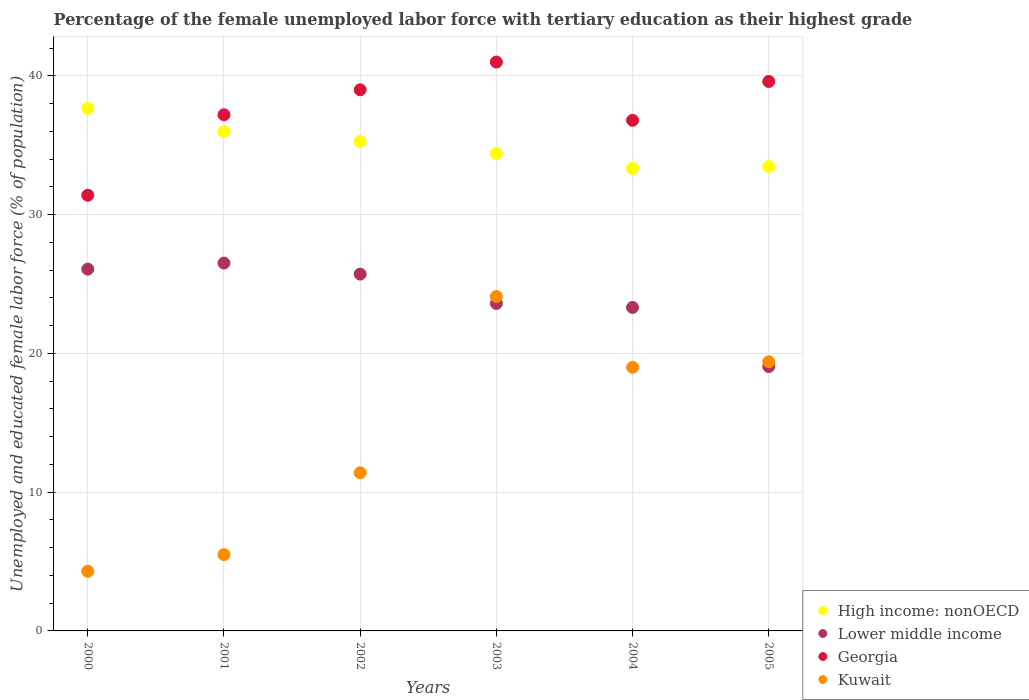How many different coloured dotlines are there?
Provide a succinct answer. 4. Across all years, what is the maximum percentage of the unemployed female labor force with tertiary education in Lower middle income?
Provide a succinct answer. 26.51. Across all years, what is the minimum percentage of the unemployed female labor force with tertiary education in Georgia?
Your response must be concise. 31.4. In which year was the percentage of the unemployed female labor force with tertiary education in Lower middle income minimum?
Your answer should be very brief. 2005. What is the total percentage of the unemployed female labor force with tertiary education in Lower middle income in the graph?
Provide a succinct answer. 144.27. What is the difference between the percentage of the unemployed female labor force with tertiary education in Lower middle income in 2002 and that in 2003?
Give a very brief answer. 2.11. What is the difference between the percentage of the unemployed female labor force with tertiary education in High income: nonOECD in 2002 and the percentage of the unemployed female labor force with tertiary education in Georgia in 2003?
Give a very brief answer. -5.73. What is the average percentage of the unemployed female labor force with tertiary education in Georgia per year?
Provide a succinct answer. 37.5. In the year 2002, what is the difference between the percentage of the unemployed female labor force with tertiary education in Kuwait and percentage of the unemployed female labor force with tertiary education in Lower middle income?
Provide a short and direct response. -14.31. What is the ratio of the percentage of the unemployed female labor force with tertiary education in High income: nonOECD in 2002 to that in 2004?
Your answer should be compact. 1.06. Is the percentage of the unemployed female labor force with tertiary education in High income: nonOECD in 2003 less than that in 2005?
Provide a short and direct response. No. Is the difference between the percentage of the unemployed female labor force with tertiary education in Kuwait in 2002 and 2005 greater than the difference between the percentage of the unemployed female labor force with tertiary education in Lower middle income in 2002 and 2005?
Offer a terse response. No. What is the difference between the highest and the second highest percentage of the unemployed female labor force with tertiary education in Georgia?
Offer a terse response. 1.4. What is the difference between the highest and the lowest percentage of the unemployed female labor force with tertiary education in Kuwait?
Provide a succinct answer. 19.8. In how many years, is the percentage of the unemployed female labor force with tertiary education in Kuwait greater than the average percentage of the unemployed female labor force with tertiary education in Kuwait taken over all years?
Provide a short and direct response. 3. Is the sum of the percentage of the unemployed female labor force with tertiary education in Lower middle income in 2001 and 2005 greater than the maximum percentage of the unemployed female labor force with tertiary education in Kuwait across all years?
Your answer should be compact. Yes. Is it the case that in every year, the sum of the percentage of the unemployed female labor force with tertiary education in Lower middle income and percentage of the unemployed female labor force with tertiary education in Georgia  is greater than the sum of percentage of the unemployed female labor force with tertiary education in High income: nonOECD and percentage of the unemployed female labor force with tertiary education in Kuwait?
Give a very brief answer. Yes. Is it the case that in every year, the sum of the percentage of the unemployed female labor force with tertiary education in Georgia and percentage of the unemployed female labor force with tertiary education in Lower middle income  is greater than the percentage of the unemployed female labor force with tertiary education in Kuwait?
Keep it short and to the point. Yes. Is the percentage of the unemployed female labor force with tertiary education in Georgia strictly greater than the percentage of the unemployed female labor force with tertiary education in High income: nonOECD over the years?
Your response must be concise. No. Is the percentage of the unemployed female labor force with tertiary education in Georgia strictly less than the percentage of the unemployed female labor force with tertiary education in Kuwait over the years?
Give a very brief answer. No. How many dotlines are there?
Offer a very short reply. 4. What is the difference between two consecutive major ticks on the Y-axis?
Your response must be concise. 10. Are the values on the major ticks of Y-axis written in scientific E-notation?
Make the answer very short. No. Does the graph contain any zero values?
Ensure brevity in your answer.  No. Does the graph contain grids?
Give a very brief answer. Yes. Where does the legend appear in the graph?
Your answer should be compact. Bottom right. How many legend labels are there?
Make the answer very short. 4. What is the title of the graph?
Your response must be concise. Percentage of the female unemployed labor force with tertiary education as their highest grade. What is the label or title of the X-axis?
Provide a succinct answer. Years. What is the label or title of the Y-axis?
Provide a succinct answer. Unemployed and educated female labor force (% of population). What is the Unemployed and educated female labor force (% of population) of High income: nonOECD in 2000?
Provide a short and direct response. 37.66. What is the Unemployed and educated female labor force (% of population) of Lower middle income in 2000?
Offer a very short reply. 26.07. What is the Unemployed and educated female labor force (% of population) of Georgia in 2000?
Your answer should be compact. 31.4. What is the Unemployed and educated female labor force (% of population) of Kuwait in 2000?
Your answer should be very brief. 4.3. What is the Unemployed and educated female labor force (% of population) of High income: nonOECD in 2001?
Provide a short and direct response. 35.98. What is the Unemployed and educated female labor force (% of population) in Lower middle income in 2001?
Offer a very short reply. 26.51. What is the Unemployed and educated female labor force (% of population) in Georgia in 2001?
Provide a short and direct response. 37.2. What is the Unemployed and educated female labor force (% of population) of High income: nonOECD in 2002?
Ensure brevity in your answer.  35.27. What is the Unemployed and educated female labor force (% of population) of Lower middle income in 2002?
Ensure brevity in your answer.  25.71. What is the Unemployed and educated female labor force (% of population) of Kuwait in 2002?
Your answer should be compact. 11.4. What is the Unemployed and educated female labor force (% of population) in High income: nonOECD in 2003?
Provide a short and direct response. 34.41. What is the Unemployed and educated female labor force (% of population) in Lower middle income in 2003?
Keep it short and to the point. 23.6. What is the Unemployed and educated female labor force (% of population) in Kuwait in 2003?
Ensure brevity in your answer.  24.1. What is the Unemployed and educated female labor force (% of population) in High income: nonOECD in 2004?
Your answer should be compact. 33.33. What is the Unemployed and educated female labor force (% of population) of Lower middle income in 2004?
Your answer should be compact. 23.32. What is the Unemployed and educated female labor force (% of population) in Georgia in 2004?
Your response must be concise. 36.8. What is the Unemployed and educated female labor force (% of population) of High income: nonOECD in 2005?
Keep it short and to the point. 33.46. What is the Unemployed and educated female labor force (% of population) of Lower middle income in 2005?
Your response must be concise. 19.05. What is the Unemployed and educated female labor force (% of population) in Georgia in 2005?
Provide a short and direct response. 39.6. What is the Unemployed and educated female labor force (% of population) of Kuwait in 2005?
Provide a short and direct response. 19.4. Across all years, what is the maximum Unemployed and educated female labor force (% of population) of High income: nonOECD?
Make the answer very short. 37.66. Across all years, what is the maximum Unemployed and educated female labor force (% of population) of Lower middle income?
Your answer should be compact. 26.51. Across all years, what is the maximum Unemployed and educated female labor force (% of population) of Kuwait?
Offer a very short reply. 24.1. Across all years, what is the minimum Unemployed and educated female labor force (% of population) of High income: nonOECD?
Provide a short and direct response. 33.33. Across all years, what is the minimum Unemployed and educated female labor force (% of population) of Lower middle income?
Provide a succinct answer. 19.05. Across all years, what is the minimum Unemployed and educated female labor force (% of population) of Georgia?
Your answer should be very brief. 31.4. Across all years, what is the minimum Unemployed and educated female labor force (% of population) in Kuwait?
Your response must be concise. 4.3. What is the total Unemployed and educated female labor force (% of population) of High income: nonOECD in the graph?
Offer a very short reply. 210.12. What is the total Unemployed and educated female labor force (% of population) in Lower middle income in the graph?
Your answer should be very brief. 144.27. What is the total Unemployed and educated female labor force (% of population) of Georgia in the graph?
Offer a very short reply. 225. What is the total Unemployed and educated female labor force (% of population) of Kuwait in the graph?
Make the answer very short. 83.7. What is the difference between the Unemployed and educated female labor force (% of population) in High income: nonOECD in 2000 and that in 2001?
Your answer should be compact. 1.68. What is the difference between the Unemployed and educated female labor force (% of population) in Lower middle income in 2000 and that in 2001?
Provide a succinct answer. -0.44. What is the difference between the Unemployed and educated female labor force (% of population) in Kuwait in 2000 and that in 2001?
Offer a terse response. -1.2. What is the difference between the Unemployed and educated female labor force (% of population) in High income: nonOECD in 2000 and that in 2002?
Your response must be concise. 2.39. What is the difference between the Unemployed and educated female labor force (% of population) of Lower middle income in 2000 and that in 2002?
Your answer should be compact. 0.36. What is the difference between the Unemployed and educated female labor force (% of population) of Georgia in 2000 and that in 2002?
Your response must be concise. -7.6. What is the difference between the Unemployed and educated female labor force (% of population) of Kuwait in 2000 and that in 2002?
Your response must be concise. -7.1. What is the difference between the Unemployed and educated female labor force (% of population) in High income: nonOECD in 2000 and that in 2003?
Offer a terse response. 3.25. What is the difference between the Unemployed and educated female labor force (% of population) in Lower middle income in 2000 and that in 2003?
Your response must be concise. 2.47. What is the difference between the Unemployed and educated female labor force (% of population) of Kuwait in 2000 and that in 2003?
Make the answer very short. -19.8. What is the difference between the Unemployed and educated female labor force (% of population) in High income: nonOECD in 2000 and that in 2004?
Your answer should be very brief. 4.34. What is the difference between the Unemployed and educated female labor force (% of population) of Lower middle income in 2000 and that in 2004?
Offer a terse response. 2.76. What is the difference between the Unemployed and educated female labor force (% of population) in Kuwait in 2000 and that in 2004?
Provide a succinct answer. -14.7. What is the difference between the Unemployed and educated female labor force (% of population) of High income: nonOECD in 2000 and that in 2005?
Offer a very short reply. 4.2. What is the difference between the Unemployed and educated female labor force (% of population) in Lower middle income in 2000 and that in 2005?
Give a very brief answer. 7.02. What is the difference between the Unemployed and educated female labor force (% of population) in Kuwait in 2000 and that in 2005?
Offer a very short reply. -15.1. What is the difference between the Unemployed and educated female labor force (% of population) in High income: nonOECD in 2001 and that in 2002?
Your response must be concise. 0.71. What is the difference between the Unemployed and educated female labor force (% of population) in Lower middle income in 2001 and that in 2002?
Make the answer very short. 0.8. What is the difference between the Unemployed and educated female labor force (% of population) in Georgia in 2001 and that in 2002?
Make the answer very short. -1.8. What is the difference between the Unemployed and educated female labor force (% of population) in High income: nonOECD in 2001 and that in 2003?
Make the answer very short. 1.57. What is the difference between the Unemployed and educated female labor force (% of population) in Lower middle income in 2001 and that in 2003?
Give a very brief answer. 2.91. What is the difference between the Unemployed and educated female labor force (% of population) of Georgia in 2001 and that in 2003?
Ensure brevity in your answer.  -3.8. What is the difference between the Unemployed and educated female labor force (% of population) in Kuwait in 2001 and that in 2003?
Your response must be concise. -18.6. What is the difference between the Unemployed and educated female labor force (% of population) of High income: nonOECD in 2001 and that in 2004?
Ensure brevity in your answer.  2.65. What is the difference between the Unemployed and educated female labor force (% of population) of Lower middle income in 2001 and that in 2004?
Make the answer very short. 3.2. What is the difference between the Unemployed and educated female labor force (% of population) of High income: nonOECD in 2001 and that in 2005?
Give a very brief answer. 2.52. What is the difference between the Unemployed and educated female labor force (% of population) of Lower middle income in 2001 and that in 2005?
Provide a short and direct response. 7.46. What is the difference between the Unemployed and educated female labor force (% of population) in High income: nonOECD in 2002 and that in 2003?
Your response must be concise. 0.86. What is the difference between the Unemployed and educated female labor force (% of population) in Lower middle income in 2002 and that in 2003?
Offer a very short reply. 2.11. What is the difference between the Unemployed and educated female labor force (% of population) of Georgia in 2002 and that in 2003?
Make the answer very short. -2. What is the difference between the Unemployed and educated female labor force (% of population) of High income: nonOECD in 2002 and that in 2004?
Your answer should be very brief. 1.95. What is the difference between the Unemployed and educated female labor force (% of population) of Lower middle income in 2002 and that in 2004?
Offer a very short reply. 2.4. What is the difference between the Unemployed and educated female labor force (% of population) in Kuwait in 2002 and that in 2004?
Your answer should be very brief. -7.6. What is the difference between the Unemployed and educated female labor force (% of population) of High income: nonOECD in 2002 and that in 2005?
Keep it short and to the point. 1.81. What is the difference between the Unemployed and educated female labor force (% of population) of Lower middle income in 2002 and that in 2005?
Your answer should be very brief. 6.66. What is the difference between the Unemployed and educated female labor force (% of population) of High income: nonOECD in 2003 and that in 2004?
Your answer should be very brief. 1.08. What is the difference between the Unemployed and educated female labor force (% of population) of Lower middle income in 2003 and that in 2004?
Your response must be concise. 0.29. What is the difference between the Unemployed and educated female labor force (% of population) in High income: nonOECD in 2003 and that in 2005?
Keep it short and to the point. 0.95. What is the difference between the Unemployed and educated female labor force (% of population) of Lower middle income in 2003 and that in 2005?
Your answer should be very brief. 4.55. What is the difference between the Unemployed and educated female labor force (% of population) in Georgia in 2003 and that in 2005?
Your answer should be very brief. 1.4. What is the difference between the Unemployed and educated female labor force (% of population) of High income: nonOECD in 2004 and that in 2005?
Provide a short and direct response. -0.14. What is the difference between the Unemployed and educated female labor force (% of population) of Lower middle income in 2004 and that in 2005?
Give a very brief answer. 4.26. What is the difference between the Unemployed and educated female labor force (% of population) in Kuwait in 2004 and that in 2005?
Your response must be concise. -0.4. What is the difference between the Unemployed and educated female labor force (% of population) in High income: nonOECD in 2000 and the Unemployed and educated female labor force (% of population) in Lower middle income in 2001?
Your answer should be compact. 11.15. What is the difference between the Unemployed and educated female labor force (% of population) in High income: nonOECD in 2000 and the Unemployed and educated female labor force (% of population) in Georgia in 2001?
Offer a terse response. 0.46. What is the difference between the Unemployed and educated female labor force (% of population) of High income: nonOECD in 2000 and the Unemployed and educated female labor force (% of population) of Kuwait in 2001?
Your response must be concise. 32.16. What is the difference between the Unemployed and educated female labor force (% of population) in Lower middle income in 2000 and the Unemployed and educated female labor force (% of population) in Georgia in 2001?
Make the answer very short. -11.13. What is the difference between the Unemployed and educated female labor force (% of population) in Lower middle income in 2000 and the Unemployed and educated female labor force (% of population) in Kuwait in 2001?
Provide a succinct answer. 20.57. What is the difference between the Unemployed and educated female labor force (% of population) of Georgia in 2000 and the Unemployed and educated female labor force (% of population) of Kuwait in 2001?
Make the answer very short. 25.9. What is the difference between the Unemployed and educated female labor force (% of population) of High income: nonOECD in 2000 and the Unemployed and educated female labor force (% of population) of Lower middle income in 2002?
Offer a very short reply. 11.95. What is the difference between the Unemployed and educated female labor force (% of population) of High income: nonOECD in 2000 and the Unemployed and educated female labor force (% of population) of Georgia in 2002?
Offer a very short reply. -1.34. What is the difference between the Unemployed and educated female labor force (% of population) in High income: nonOECD in 2000 and the Unemployed and educated female labor force (% of population) in Kuwait in 2002?
Offer a terse response. 26.26. What is the difference between the Unemployed and educated female labor force (% of population) in Lower middle income in 2000 and the Unemployed and educated female labor force (% of population) in Georgia in 2002?
Offer a very short reply. -12.93. What is the difference between the Unemployed and educated female labor force (% of population) of Lower middle income in 2000 and the Unemployed and educated female labor force (% of population) of Kuwait in 2002?
Provide a short and direct response. 14.67. What is the difference between the Unemployed and educated female labor force (% of population) in Georgia in 2000 and the Unemployed and educated female labor force (% of population) in Kuwait in 2002?
Make the answer very short. 20. What is the difference between the Unemployed and educated female labor force (% of population) of High income: nonOECD in 2000 and the Unemployed and educated female labor force (% of population) of Lower middle income in 2003?
Give a very brief answer. 14.06. What is the difference between the Unemployed and educated female labor force (% of population) of High income: nonOECD in 2000 and the Unemployed and educated female labor force (% of population) of Georgia in 2003?
Give a very brief answer. -3.34. What is the difference between the Unemployed and educated female labor force (% of population) in High income: nonOECD in 2000 and the Unemployed and educated female labor force (% of population) in Kuwait in 2003?
Provide a succinct answer. 13.56. What is the difference between the Unemployed and educated female labor force (% of population) in Lower middle income in 2000 and the Unemployed and educated female labor force (% of population) in Georgia in 2003?
Keep it short and to the point. -14.93. What is the difference between the Unemployed and educated female labor force (% of population) in Lower middle income in 2000 and the Unemployed and educated female labor force (% of population) in Kuwait in 2003?
Offer a very short reply. 1.97. What is the difference between the Unemployed and educated female labor force (% of population) of High income: nonOECD in 2000 and the Unemployed and educated female labor force (% of population) of Lower middle income in 2004?
Your answer should be compact. 14.35. What is the difference between the Unemployed and educated female labor force (% of population) of High income: nonOECD in 2000 and the Unemployed and educated female labor force (% of population) of Georgia in 2004?
Keep it short and to the point. 0.86. What is the difference between the Unemployed and educated female labor force (% of population) of High income: nonOECD in 2000 and the Unemployed and educated female labor force (% of population) of Kuwait in 2004?
Give a very brief answer. 18.66. What is the difference between the Unemployed and educated female labor force (% of population) of Lower middle income in 2000 and the Unemployed and educated female labor force (% of population) of Georgia in 2004?
Give a very brief answer. -10.73. What is the difference between the Unemployed and educated female labor force (% of population) in Lower middle income in 2000 and the Unemployed and educated female labor force (% of population) in Kuwait in 2004?
Your answer should be very brief. 7.07. What is the difference between the Unemployed and educated female labor force (% of population) of High income: nonOECD in 2000 and the Unemployed and educated female labor force (% of population) of Lower middle income in 2005?
Give a very brief answer. 18.61. What is the difference between the Unemployed and educated female labor force (% of population) in High income: nonOECD in 2000 and the Unemployed and educated female labor force (% of population) in Georgia in 2005?
Your answer should be compact. -1.94. What is the difference between the Unemployed and educated female labor force (% of population) of High income: nonOECD in 2000 and the Unemployed and educated female labor force (% of population) of Kuwait in 2005?
Offer a terse response. 18.26. What is the difference between the Unemployed and educated female labor force (% of population) of Lower middle income in 2000 and the Unemployed and educated female labor force (% of population) of Georgia in 2005?
Give a very brief answer. -13.53. What is the difference between the Unemployed and educated female labor force (% of population) of Lower middle income in 2000 and the Unemployed and educated female labor force (% of population) of Kuwait in 2005?
Keep it short and to the point. 6.67. What is the difference between the Unemployed and educated female labor force (% of population) in High income: nonOECD in 2001 and the Unemployed and educated female labor force (% of population) in Lower middle income in 2002?
Your answer should be very brief. 10.27. What is the difference between the Unemployed and educated female labor force (% of population) in High income: nonOECD in 2001 and the Unemployed and educated female labor force (% of population) in Georgia in 2002?
Give a very brief answer. -3.02. What is the difference between the Unemployed and educated female labor force (% of population) of High income: nonOECD in 2001 and the Unemployed and educated female labor force (% of population) of Kuwait in 2002?
Give a very brief answer. 24.58. What is the difference between the Unemployed and educated female labor force (% of population) of Lower middle income in 2001 and the Unemployed and educated female labor force (% of population) of Georgia in 2002?
Your answer should be compact. -12.49. What is the difference between the Unemployed and educated female labor force (% of population) of Lower middle income in 2001 and the Unemployed and educated female labor force (% of population) of Kuwait in 2002?
Keep it short and to the point. 15.11. What is the difference between the Unemployed and educated female labor force (% of population) of Georgia in 2001 and the Unemployed and educated female labor force (% of population) of Kuwait in 2002?
Your answer should be very brief. 25.8. What is the difference between the Unemployed and educated female labor force (% of population) in High income: nonOECD in 2001 and the Unemployed and educated female labor force (% of population) in Lower middle income in 2003?
Ensure brevity in your answer.  12.38. What is the difference between the Unemployed and educated female labor force (% of population) of High income: nonOECD in 2001 and the Unemployed and educated female labor force (% of population) of Georgia in 2003?
Provide a short and direct response. -5.02. What is the difference between the Unemployed and educated female labor force (% of population) in High income: nonOECD in 2001 and the Unemployed and educated female labor force (% of population) in Kuwait in 2003?
Ensure brevity in your answer.  11.88. What is the difference between the Unemployed and educated female labor force (% of population) in Lower middle income in 2001 and the Unemployed and educated female labor force (% of population) in Georgia in 2003?
Keep it short and to the point. -14.49. What is the difference between the Unemployed and educated female labor force (% of population) in Lower middle income in 2001 and the Unemployed and educated female labor force (% of population) in Kuwait in 2003?
Give a very brief answer. 2.41. What is the difference between the Unemployed and educated female labor force (% of population) in High income: nonOECD in 2001 and the Unemployed and educated female labor force (% of population) in Lower middle income in 2004?
Keep it short and to the point. 12.67. What is the difference between the Unemployed and educated female labor force (% of population) of High income: nonOECD in 2001 and the Unemployed and educated female labor force (% of population) of Georgia in 2004?
Your answer should be very brief. -0.82. What is the difference between the Unemployed and educated female labor force (% of population) in High income: nonOECD in 2001 and the Unemployed and educated female labor force (% of population) in Kuwait in 2004?
Ensure brevity in your answer.  16.98. What is the difference between the Unemployed and educated female labor force (% of population) in Lower middle income in 2001 and the Unemployed and educated female labor force (% of population) in Georgia in 2004?
Offer a terse response. -10.29. What is the difference between the Unemployed and educated female labor force (% of population) of Lower middle income in 2001 and the Unemployed and educated female labor force (% of population) of Kuwait in 2004?
Keep it short and to the point. 7.51. What is the difference between the Unemployed and educated female labor force (% of population) in Georgia in 2001 and the Unemployed and educated female labor force (% of population) in Kuwait in 2004?
Your answer should be very brief. 18.2. What is the difference between the Unemployed and educated female labor force (% of population) in High income: nonOECD in 2001 and the Unemployed and educated female labor force (% of population) in Lower middle income in 2005?
Your response must be concise. 16.93. What is the difference between the Unemployed and educated female labor force (% of population) of High income: nonOECD in 2001 and the Unemployed and educated female labor force (% of population) of Georgia in 2005?
Your answer should be very brief. -3.62. What is the difference between the Unemployed and educated female labor force (% of population) in High income: nonOECD in 2001 and the Unemployed and educated female labor force (% of population) in Kuwait in 2005?
Your answer should be very brief. 16.58. What is the difference between the Unemployed and educated female labor force (% of population) of Lower middle income in 2001 and the Unemployed and educated female labor force (% of population) of Georgia in 2005?
Your response must be concise. -13.09. What is the difference between the Unemployed and educated female labor force (% of population) in Lower middle income in 2001 and the Unemployed and educated female labor force (% of population) in Kuwait in 2005?
Keep it short and to the point. 7.11. What is the difference between the Unemployed and educated female labor force (% of population) in High income: nonOECD in 2002 and the Unemployed and educated female labor force (% of population) in Lower middle income in 2003?
Give a very brief answer. 11.67. What is the difference between the Unemployed and educated female labor force (% of population) of High income: nonOECD in 2002 and the Unemployed and educated female labor force (% of population) of Georgia in 2003?
Your response must be concise. -5.73. What is the difference between the Unemployed and educated female labor force (% of population) of High income: nonOECD in 2002 and the Unemployed and educated female labor force (% of population) of Kuwait in 2003?
Provide a short and direct response. 11.17. What is the difference between the Unemployed and educated female labor force (% of population) of Lower middle income in 2002 and the Unemployed and educated female labor force (% of population) of Georgia in 2003?
Your answer should be very brief. -15.29. What is the difference between the Unemployed and educated female labor force (% of population) in Lower middle income in 2002 and the Unemployed and educated female labor force (% of population) in Kuwait in 2003?
Give a very brief answer. 1.61. What is the difference between the Unemployed and educated female labor force (% of population) in Georgia in 2002 and the Unemployed and educated female labor force (% of population) in Kuwait in 2003?
Provide a succinct answer. 14.9. What is the difference between the Unemployed and educated female labor force (% of population) of High income: nonOECD in 2002 and the Unemployed and educated female labor force (% of population) of Lower middle income in 2004?
Make the answer very short. 11.96. What is the difference between the Unemployed and educated female labor force (% of population) in High income: nonOECD in 2002 and the Unemployed and educated female labor force (% of population) in Georgia in 2004?
Provide a short and direct response. -1.53. What is the difference between the Unemployed and educated female labor force (% of population) of High income: nonOECD in 2002 and the Unemployed and educated female labor force (% of population) of Kuwait in 2004?
Offer a very short reply. 16.27. What is the difference between the Unemployed and educated female labor force (% of population) in Lower middle income in 2002 and the Unemployed and educated female labor force (% of population) in Georgia in 2004?
Offer a terse response. -11.09. What is the difference between the Unemployed and educated female labor force (% of population) in Lower middle income in 2002 and the Unemployed and educated female labor force (% of population) in Kuwait in 2004?
Your response must be concise. 6.71. What is the difference between the Unemployed and educated female labor force (% of population) in Georgia in 2002 and the Unemployed and educated female labor force (% of population) in Kuwait in 2004?
Your answer should be very brief. 20. What is the difference between the Unemployed and educated female labor force (% of population) in High income: nonOECD in 2002 and the Unemployed and educated female labor force (% of population) in Lower middle income in 2005?
Give a very brief answer. 16.22. What is the difference between the Unemployed and educated female labor force (% of population) of High income: nonOECD in 2002 and the Unemployed and educated female labor force (% of population) of Georgia in 2005?
Your answer should be very brief. -4.33. What is the difference between the Unemployed and educated female labor force (% of population) of High income: nonOECD in 2002 and the Unemployed and educated female labor force (% of population) of Kuwait in 2005?
Ensure brevity in your answer.  15.87. What is the difference between the Unemployed and educated female labor force (% of population) of Lower middle income in 2002 and the Unemployed and educated female labor force (% of population) of Georgia in 2005?
Keep it short and to the point. -13.89. What is the difference between the Unemployed and educated female labor force (% of population) of Lower middle income in 2002 and the Unemployed and educated female labor force (% of population) of Kuwait in 2005?
Make the answer very short. 6.31. What is the difference between the Unemployed and educated female labor force (% of population) in Georgia in 2002 and the Unemployed and educated female labor force (% of population) in Kuwait in 2005?
Your answer should be compact. 19.6. What is the difference between the Unemployed and educated female labor force (% of population) in High income: nonOECD in 2003 and the Unemployed and educated female labor force (% of population) in Lower middle income in 2004?
Offer a very short reply. 11.1. What is the difference between the Unemployed and educated female labor force (% of population) of High income: nonOECD in 2003 and the Unemployed and educated female labor force (% of population) of Georgia in 2004?
Your answer should be compact. -2.39. What is the difference between the Unemployed and educated female labor force (% of population) in High income: nonOECD in 2003 and the Unemployed and educated female labor force (% of population) in Kuwait in 2004?
Your response must be concise. 15.41. What is the difference between the Unemployed and educated female labor force (% of population) of Lower middle income in 2003 and the Unemployed and educated female labor force (% of population) of Georgia in 2004?
Offer a very short reply. -13.2. What is the difference between the Unemployed and educated female labor force (% of population) of Lower middle income in 2003 and the Unemployed and educated female labor force (% of population) of Kuwait in 2004?
Give a very brief answer. 4.6. What is the difference between the Unemployed and educated female labor force (% of population) in High income: nonOECD in 2003 and the Unemployed and educated female labor force (% of population) in Lower middle income in 2005?
Make the answer very short. 15.36. What is the difference between the Unemployed and educated female labor force (% of population) of High income: nonOECD in 2003 and the Unemployed and educated female labor force (% of population) of Georgia in 2005?
Your answer should be compact. -5.19. What is the difference between the Unemployed and educated female labor force (% of population) in High income: nonOECD in 2003 and the Unemployed and educated female labor force (% of population) in Kuwait in 2005?
Your answer should be very brief. 15.01. What is the difference between the Unemployed and educated female labor force (% of population) in Lower middle income in 2003 and the Unemployed and educated female labor force (% of population) in Georgia in 2005?
Ensure brevity in your answer.  -16. What is the difference between the Unemployed and educated female labor force (% of population) of Lower middle income in 2003 and the Unemployed and educated female labor force (% of population) of Kuwait in 2005?
Keep it short and to the point. 4.2. What is the difference between the Unemployed and educated female labor force (% of population) of Georgia in 2003 and the Unemployed and educated female labor force (% of population) of Kuwait in 2005?
Give a very brief answer. 21.6. What is the difference between the Unemployed and educated female labor force (% of population) in High income: nonOECD in 2004 and the Unemployed and educated female labor force (% of population) in Lower middle income in 2005?
Provide a short and direct response. 14.27. What is the difference between the Unemployed and educated female labor force (% of population) of High income: nonOECD in 2004 and the Unemployed and educated female labor force (% of population) of Georgia in 2005?
Your response must be concise. -6.27. What is the difference between the Unemployed and educated female labor force (% of population) in High income: nonOECD in 2004 and the Unemployed and educated female labor force (% of population) in Kuwait in 2005?
Provide a short and direct response. 13.93. What is the difference between the Unemployed and educated female labor force (% of population) of Lower middle income in 2004 and the Unemployed and educated female labor force (% of population) of Georgia in 2005?
Provide a short and direct response. -16.28. What is the difference between the Unemployed and educated female labor force (% of population) in Lower middle income in 2004 and the Unemployed and educated female labor force (% of population) in Kuwait in 2005?
Keep it short and to the point. 3.92. What is the average Unemployed and educated female labor force (% of population) of High income: nonOECD per year?
Your response must be concise. 35.02. What is the average Unemployed and educated female labor force (% of population) of Lower middle income per year?
Your answer should be compact. 24.04. What is the average Unemployed and educated female labor force (% of population) in Georgia per year?
Provide a succinct answer. 37.5. What is the average Unemployed and educated female labor force (% of population) in Kuwait per year?
Offer a terse response. 13.95. In the year 2000, what is the difference between the Unemployed and educated female labor force (% of population) of High income: nonOECD and Unemployed and educated female labor force (% of population) of Lower middle income?
Make the answer very short. 11.59. In the year 2000, what is the difference between the Unemployed and educated female labor force (% of population) of High income: nonOECD and Unemployed and educated female labor force (% of population) of Georgia?
Your answer should be very brief. 6.26. In the year 2000, what is the difference between the Unemployed and educated female labor force (% of population) of High income: nonOECD and Unemployed and educated female labor force (% of population) of Kuwait?
Your answer should be compact. 33.36. In the year 2000, what is the difference between the Unemployed and educated female labor force (% of population) in Lower middle income and Unemployed and educated female labor force (% of population) in Georgia?
Make the answer very short. -5.33. In the year 2000, what is the difference between the Unemployed and educated female labor force (% of population) in Lower middle income and Unemployed and educated female labor force (% of population) in Kuwait?
Your answer should be very brief. 21.77. In the year 2000, what is the difference between the Unemployed and educated female labor force (% of population) in Georgia and Unemployed and educated female labor force (% of population) in Kuwait?
Make the answer very short. 27.1. In the year 2001, what is the difference between the Unemployed and educated female labor force (% of population) of High income: nonOECD and Unemployed and educated female labor force (% of population) of Lower middle income?
Provide a short and direct response. 9.47. In the year 2001, what is the difference between the Unemployed and educated female labor force (% of population) in High income: nonOECD and Unemployed and educated female labor force (% of population) in Georgia?
Keep it short and to the point. -1.22. In the year 2001, what is the difference between the Unemployed and educated female labor force (% of population) in High income: nonOECD and Unemployed and educated female labor force (% of population) in Kuwait?
Keep it short and to the point. 30.48. In the year 2001, what is the difference between the Unemployed and educated female labor force (% of population) of Lower middle income and Unemployed and educated female labor force (% of population) of Georgia?
Your answer should be compact. -10.69. In the year 2001, what is the difference between the Unemployed and educated female labor force (% of population) of Lower middle income and Unemployed and educated female labor force (% of population) of Kuwait?
Your answer should be very brief. 21.01. In the year 2001, what is the difference between the Unemployed and educated female labor force (% of population) in Georgia and Unemployed and educated female labor force (% of population) in Kuwait?
Your answer should be compact. 31.7. In the year 2002, what is the difference between the Unemployed and educated female labor force (% of population) of High income: nonOECD and Unemployed and educated female labor force (% of population) of Lower middle income?
Offer a terse response. 9.56. In the year 2002, what is the difference between the Unemployed and educated female labor force (% of population) in High income: nonOECD and Unemployed and educated female labor force (% of population) in Georgia?
Make the answer very short. -3.73. In the year 2002, what is the difference between the Unemployed and educated female labor force (% of population) of High income: nonOECD and Unemployed and educated female labor force (% of population) of Kuwait?
Ensure brevity in your answer.  23.87. In the year 2002, what is the difference between the Unemployed and educated female labor force (% of population) in Lower middle income and Unemployed and educated female labor force (% of population) in Georgia?
Your answer should be very brief. -13.29. In the year 2002, what is the difference between the Unemployed and educated female labor force (% of population) of Lower middle income and Unemployed and educated female labor force (% of population) of Kuwait?
Your answer should be compact. 14.31. In the year 2002, what is the difference between the Unemployed and educated female labor force (% of population) of Georgia and Unemployed and educated female labor force (% of population) of Kuwait?
Keep it short and to the point. 27.6. In the year 2003, what is the difference between the Unemployed and educated female labor force (% of population) in High income: nonOECD and Unemployed and educated female labor force (% of population) in Lower middle income?
Your answer should be very brief. 10.81. In the year 2003, what is the difference between the Unemployed and educated female labor force (% of population) in High income: nonOECD and Unemployed and educated female labor force (% of population) in Georgia?
Your response must be concise. -6.59. In the year 2003, what is the difference between the Unemployed and educated female labor force (% of population) of High income: nonOECD and Unemployed and educated female labor force (% of population) of Kuwait?
Ensure brevity in your answer.  10.31. In the year 2003, what is the difference between the Unemployed and educated female labor force (% of population) in Lower middle income and Unemployed and educated female labor force (% of population) in Georgia?
Offer a very short reply. -17.4. In the year 2003, what is the difference between the Unemployed and educated female labor force (% of population) of Lower middle income and Unemployed and educated female labor force (% of population) of Kuwait?
Provide a succinct answer. -0.5. In the year 2004, what is the difference between the Unemployed and educated female labor force (% of population) in High income: nonOECD and Unemployed and educated female labor force (% of population) in Lower middle income?
Ensure brevity in your answer.  10.01. In the year 2004, what is the difference between the Unemployed and educated female labor force (% of population) of High income: nonOECD and Unemployed and educated female labor force (% of population) of Georgia?
Offer a terse response. -3.47. In the year 2004, what is the difference between the Unemployed and educated female labor force (% of population) of High income: nonOECD and Unemployed and educated female labor force (% of population) of Kuwait?
Offer a very short reply. 14.33. In the year 2004, what is the difference between the Unemployed and educated female labor force (% of population) in Lower middle income and Unemployed and educated female labor force (% of population) in Georgia?
Your answer should be compact. -13.48. In the year 2004, what is the difference between the Unemployed and educated female labor force (% of population) of Lower middle income and Unemployed and educated female labor force (% of population) of Kuwait?
Give a very brief answer. 4.32. In the year 2005, what is the difference between the Unemployed and educated female labor force (% of population) in High income: nonOECD and Unemployed and educated female labor force (% of population) in Lower middle income?
Make the answer very short. 14.41. In the year 2005, what is the difference between the Unemployed and educated female labor force (% of population) in High income: nonOECD and Unemployed and educated female labor force (% of population) in Georgia?
Offer a very short reply. -6.14. In the year 2005, what is the difference between the Unemployed and educated female labor force (% of population) of High income: nonOECD and Unemployed and educated female labor force (% of population) of Kuwait?
Your response must be concise. 14.06. In the year 2005, what is the difference between the Unemployed and educated female labor force (% of population) of Lower middle income and Unemployed and educated female labor force (% of population) of Georgia?
Your answer should be compact. -20.55. In the year 2005, what is the difference between the Unemployed and educated female labor force (% of population) of Lower middle income and Unemployed and educated female labor force (% of population) of Kuwait?
Give a very brief answer. -0.35. In the year 2005, what is the difference between the Unemployed and educated female labor force (% of population) in Georgia and Unemployed and educated female labor force (% of population) in Kuwait?
Your response must be concise. 20.2. What is the ratio of the Unemployed and educated female labor force (% of population) of High income: nonOECD in 2000 to that in 2001?
Provide a short and direct response. 1.05. What is the ratio of the Unemployed and educated female labor force (% of population) of Lower middle income in 2000 to that in 2001?
Your answer should be very brief. 0.98. What is the ratio of the Unemployed and educated female labor force (% of population) in Georgia in 2000 to that in 2001?
Make the answer very short. 0.84. What is the ratio of the Unemployed and educated female labor force (% of population) in Kuwait in 2000 to that in 2001?
Offer a terse response. 0.78. What is the ratio of the Unemployed and educated female labor force (% of population) in High income: nonOECD in 2000 to that in 2002?
Your answer should be compact. 1.07. What is the ratio of the Unemployed and educated female labor force (% of population) of Georgia in 2000 to that in 2002?
Ensure brevity in your answer.  0.81. What is the ratio of the Unemployed and educated female labor force (% of population) in Kuwait in 2000 to that in 2002?
Offer a very short reply. 0.38. What is the ratio of the Unemployed and educated female labor force (% of population) in High income: nonOECD in 2000 to that in 2003?
Make the answer very short. 1.09. What is the ratio of the Unemployed and educated female labor force (% of population) in Lower middle income in 2000 to that in 2003?
Provide a succinct answer. 1.1. What is the ratio of the Unemployed and educated female labor force (% of population) in Georgia in 2000 to that in 2003?
Provide a short and direct response. 0.77. What is the ratio of the Unemployed and educated female labor force (% of population) of Kuwait in 2000 to that in 2003?
Keep it short and to the point. 0.18. What is the ratio of the Unemployed and educated female labor force (% of population) in High income: nonOECD in 2000 to that in 2004?
Provide a short and direct response. 1.13. What is the ratio of the Unemployed and educated female labor force (% of population) in Lower middle income in 2000 to that in 2004?
Offer a terse response. 1.12. What is the ratio of the Unemployed and educated female labor force (% of population) of Georgia in 2000 to that in 2004?
Ensure brevity in your answer.  0.85. What is the ratio of the Unemployed and educated female labor force (% of population) in Kuwait in 2000 to that in 2004?
Give a very brief answer. 0.23. What is the ratio of the Unemployed and educated female labor force (% of population) of High income: nonOECD in 2000 to that in 2005?
Offer a terse response. 1.13. What is the ratio of the Unemployed and educated female labor force (% of population) in Lower middle income in 2000 to that in 2005?
Provide a succinct answer. 1.37. What is the ratio of the Unemployed and educated female labor force (% of population) of Georgia in 2000 to that in 2005?
Your response must be concise. 0.79. What is the ratio of the Unemployed and educated female labor force (% of population) in Kuwait in 2000 to that in 2005?
Keep it short and to the point. 0.22. What is the ratio of the Unemployed and educated female labor force (% of population) of High income: nonOECD in 2001 to that in 2002?
Your response must be concise. 1.02. What is the ratio of the Unemployed and educated female labor force (% of population) of Lower middle income in 2001 to that in 2002?
Your answer should be very brief. 1.03. What is the ratio of the Unemployed and educated female labor force (% of population) in Georgia in 2001 to that in 2002?
Offer a terse response. 0.95. What is the ratio of the Unemployed and educated female labor force (% of population) of Kuwait in 2001 to that in 2002?
Keep it short and to the point. 0.48. What is the ratio of the Unemployed and educated female labor force (% of population) in High income: nonOECD in 2001 to that in 2003?
Keep it short and to the point. 1.05. What is the ratio of the Unemployed and educated female labor force (% of population) of Lower middle income in 2001 to that in 2003?
Your answer should be very brief. 1.12. What is the ratio of the Unemployed and educated female labor force (% of population) in Georgia in 2001 to that in 2003?
Keep it short and to the point. 0.91. What is the ratio of the Unemployed and educated female labor force (% of population) of Kuwait in 2001 to that in 2003?
Offer a very short reply. 0.23. What is the ratio of the Unemployed and educated female labor force (% of population) in High income: nonOECD in 2001 to that in 2004?
Your response must be concise. 1.08. What is the ratio of the Unemployed and educated female labor force (% of population) of Lower middle income in 2001 to that in 2004?
Make the answer very short. 1.14. What is the ratio of the Unemployed and educated female labor force (% of population) of Georgia in 2001 to that in 2004?
Provide a short and direct response. 1.01. What is the ratio of the Unemployed and educated female labor force (% of population) of Kuwait in 2001 to that in 2004?
Make the answer very short. 0.29. What is the ratio of the Unemployed and educated female labor force (% of population) in High income: nonOECD in 2001 to that in 2005?
Provide a short and direct response. 1.08. What is the ratio of the Unemployed and educated female labor force (% of population) of Lower middle income in 2001 to that in 2005?
Give a very brief answer. 1.39. What is the ratio of the Unemployed and educated female labor force (% of population) in Georgia in 2001 to that in 2005?
Provide a short and direct response. 0.94. What is the ratio of the Unemployed and educated female labor force (% of population) in Kuwait in 2001 to that in 2005?
Keep it short and to the point. 0.28. What is the ratio of the Unemployed and educated female labor force (% of population) of High income: nonOECD in 2002 to that in 2003?
Your answer should be compact. 1.03. What is the ratio of the Unemployed and educated female labor force (% of population) of Lower middle income in 2002 to that in 2003?
Your response must be concise. 1.09. What is the ratio of the Unemployed and educated female labor force (% of population) in Georgia in 2002 to that in 2003?
Make the answer very short. 0.95. What is the ratio of the Unemployed and educated female labor force (% of population) in Kuwait in 2002 to that in 2003?
Your answer should be very brief. 0.47. What is the ratio of the Unemployed and educated female labor force (% of population) in High income: nonOECD in 2002 to that in 2004?
Your answer should be very brief. 1.06. What is the ratio of the Unemployed and educated female labor force (% of population) of Lower middle income in 2002 to that in 2004?
Offer a terse response. 1.1. What is the ratio of the Unemployed and educated female labor force (% of population) of Georgia in 2002 to that in 2004?
Provide a succinct answer. 1.06. What is the ratio of the Unemployed and educated female labor force (% of population) of Kuwait in 2002 to that in 2004?
Provide a succinct answer. 0.6. What is the ratio of the Unemployed and educated female labor force (% of population) in High income: nonOECD in 2002 to that in 2005?
Ensure brevity in your answer.  1.05. What is the ratio of the Unemployed and educated female labor force (% of population) in Lower middle income in 2002 to that in 2005?
Make the answer very short. 1.35. What is the ratio of the Unemployed and educated female labor force (% of population) of Georgia in 2002 to that in 2005?
Offer a terse response. 0.98. What is the ratio of the Unemployed and educated female labor force (% of population) in Kuwait in 2002 to that in 2005?
Offer a terse response. 0.59. What is the ratio of the Unemployed and educated female labor force (% of population) in High income: nonOECD in 2003 to that in 2004?
Offer a terse response. 1.03. What is the ratio of the Unemployed and educated female labor force (% of population) of Lower middle income in 2003 to that in 2004?
Provide a short and direct response. 1.01. What is the ratio of the Unemployed and educated female labor force (% of population) of Georgia in 2003 to that in 2004?
Provide a succinct answer. 1.11. What is the ratio of the Unemployed and educated female labor force (% of population) in Kuwait in 2003 to that in 2004?
Offer a very short reply. 1.27. What is the ratio of the Unemployed and educated female labor force (% of population) of High income: nonOECD in 2003 to that in 2005?
Provide a succinct answer. 1.03. What is the ratio of the Unemployed and educated female labor force (% of population) of Lower middle income in 2003 to that in 2005?
Make the answer very short. 1.24. What is the ratio of the Unemployed and educated female labor force (% of population) of Georgia in 2003 to that in 2005?
Offer a very short reply. 1.04. What is the ratio of the Unemployed and educated female labor force (% of population) of Kuwait in 2003 to that in 2005?
Provide a succinct answer. 1.24. What is the ratio of the Unemployed and educated female labor force (% of population) in High income: nonOECD in 2004 to that in 2005?
Make the answer very short. 1. What is the ratio of the Unemployed and educated female labor force (% of population) of Lower middle income in 2004 to that in 2005?
Give a very brief answer. 1.22. What is the ratio of the Unemployed and educated female labor force (% of population) of Georgia in 2004 to that in 2005?
Provide a succinct answer. 0.93. What is the ratio of the Unemployed and educated female labor force (% of population) in Kuwait in 2004 to that in 2005?
Give a very brief answer. 0.98. What is the difference between the highest and the second highest Unemployed and educated female labor force (% of population) in High income: nonOECD?
Make the answer very short. 1.68. What is the difference between the highest and the second highest Unemployed and educated female labor force (% of population) of Lower middle income?
Offer a terse response. 0.44. What is the difference between the highest and the lowest Unemployed and educated female labor force (% of population) of High income: nonOECD?
Make the answer very short. 4.34. What is the difference between the highest and the lowest Unemployed and educated female labor force (% of population) in Lower middle income?
Your answer should be compact. 7.46. What is the difference between the highest and the lowest Unemployed and educated female labor force (% of population) in Kuwait?
Your answer should be very brief. 19.8. 